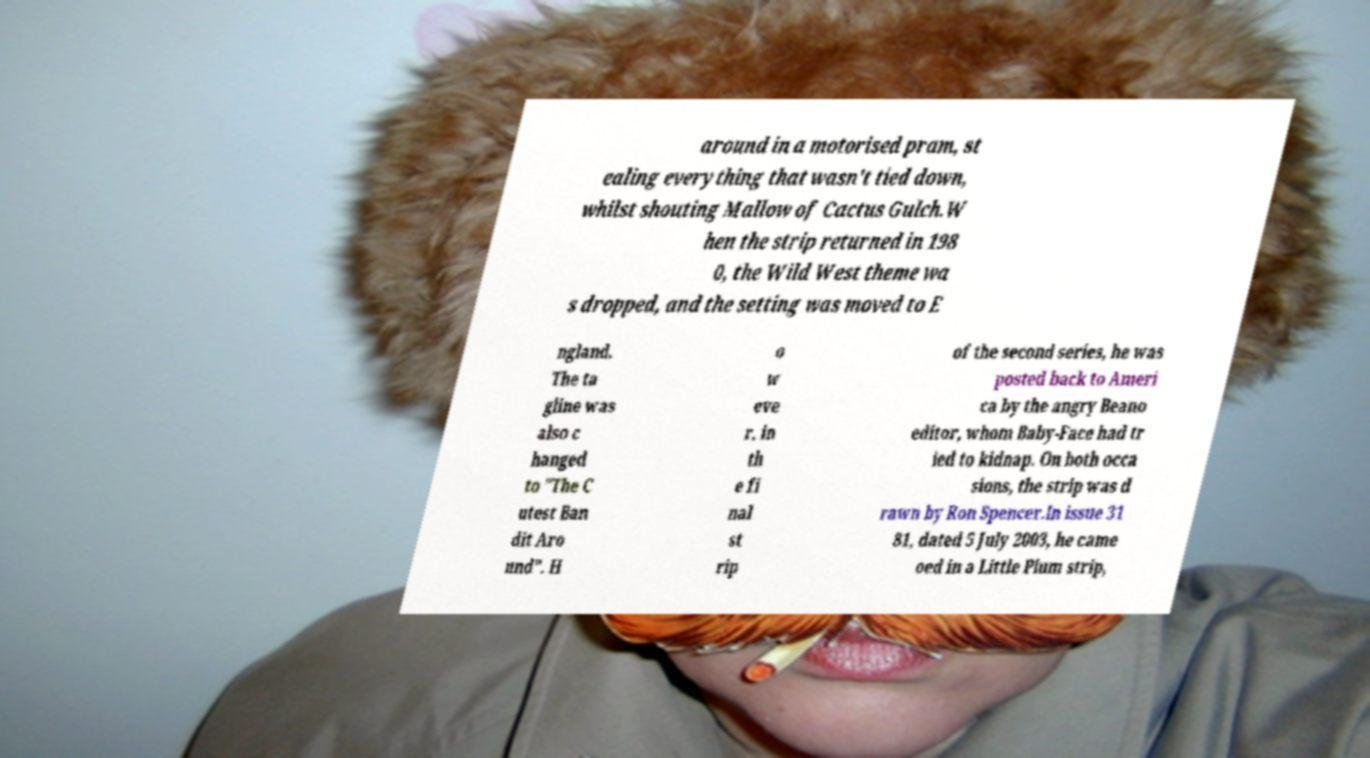What messages or text are displayed in this image? I need them in a readable, typed format. around in a motorised pram, st ealing everything that wasn't tied down, whilst shouting Mallow of Cactus Gulch.W hen the strip returned in 198 0, the Wild West theme wa s dropped, and the setting was moved to E ngland. The ta gline was also c hanged to "The C utest Ban dit Aro und". H o w eve r, in th e fi nal st rip of the second series, he was posted back to Ameri ca by the angry Beano editor, whom Baby-Face had tr ied to kidnap. On both occa sions, the strip was d rawn by Ron Spencer.In issue 31 81, dated 5 July 2003, he came oed in a Little Plum strip, 